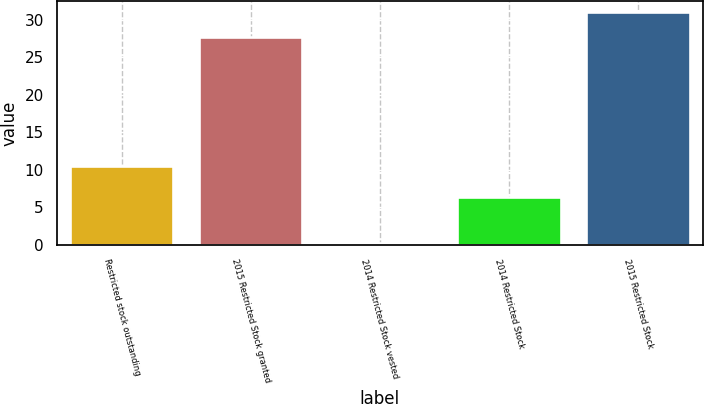Convert chart. <chart><loc_0><loc_0><loc_500><loc_500><bar_chart><fcel>Restricted stock outstanding<fcel>2015 Restricted Stock granted<fcel>2014 Restricted Stock vested<fcel>2014 Restricted Stock<fcel>2015 Restricted Stock<nl><fcel>10.45<fcel>27.65<fcel>0.2<fcel>6.36<fcel>30.95<nl></chart> 